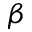<formula> <loc_0><loc_0><loc_500><loc_500>\beta</formula> 